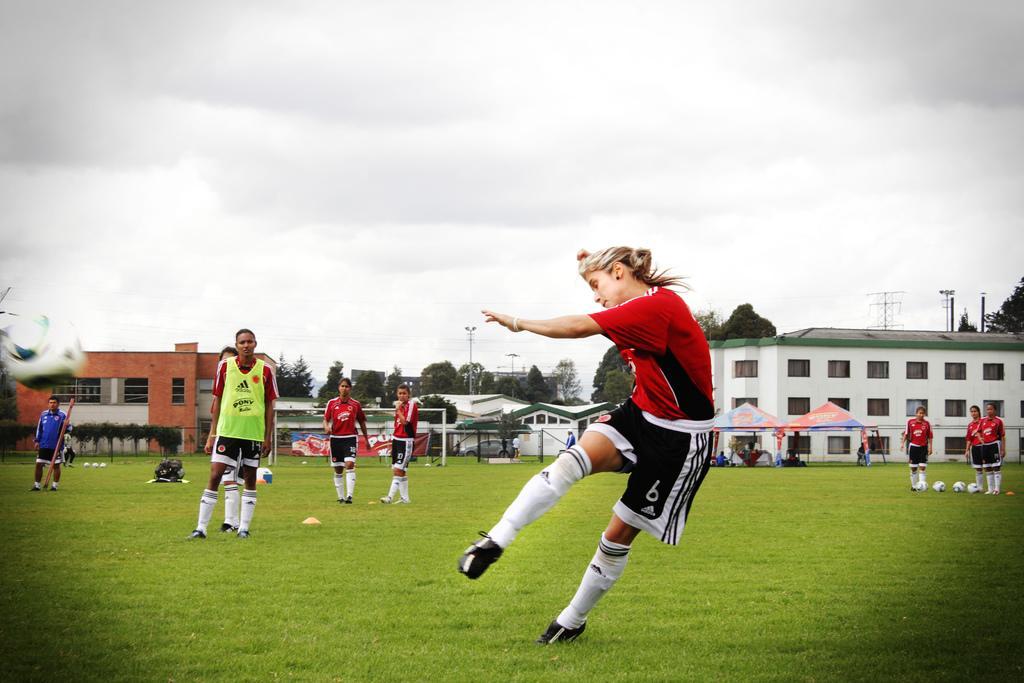Could you give a brief overview of what you see in this image? There are persons in different color dresses, playing football on the grass on the ground. On the left side, there is a standing. On the right side, there are three persons in red color t-shirts standing on the ground. Beside them, there are three balls on the ground. In the background, there are tents arranged on the ground, there are buildings, plants, trees and there are clouds in the sky. 